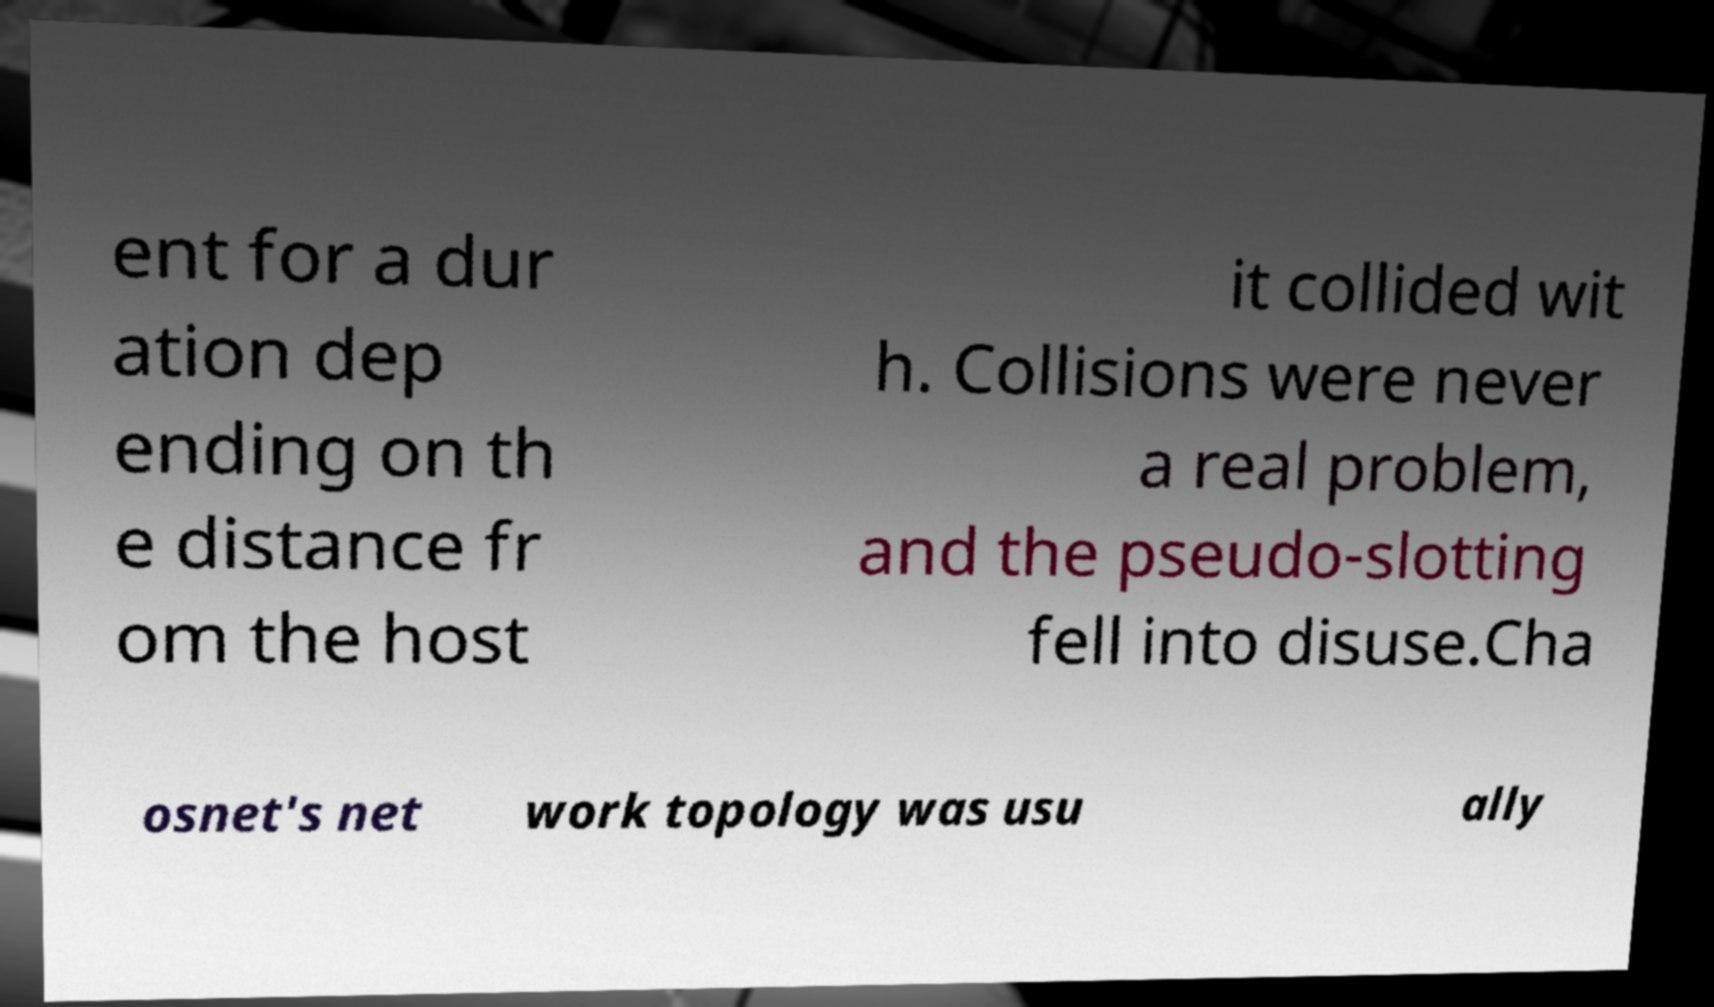There's text embedded in this image that I need extracted. Can you transcribe it verbatim? ent for a dur ation dep ending on th e distance fr om the host it collided wit h. Collisions were never a real problem, and the pseudo-slotting fell into disuse.Cha osnet's net work topology was usu ally 